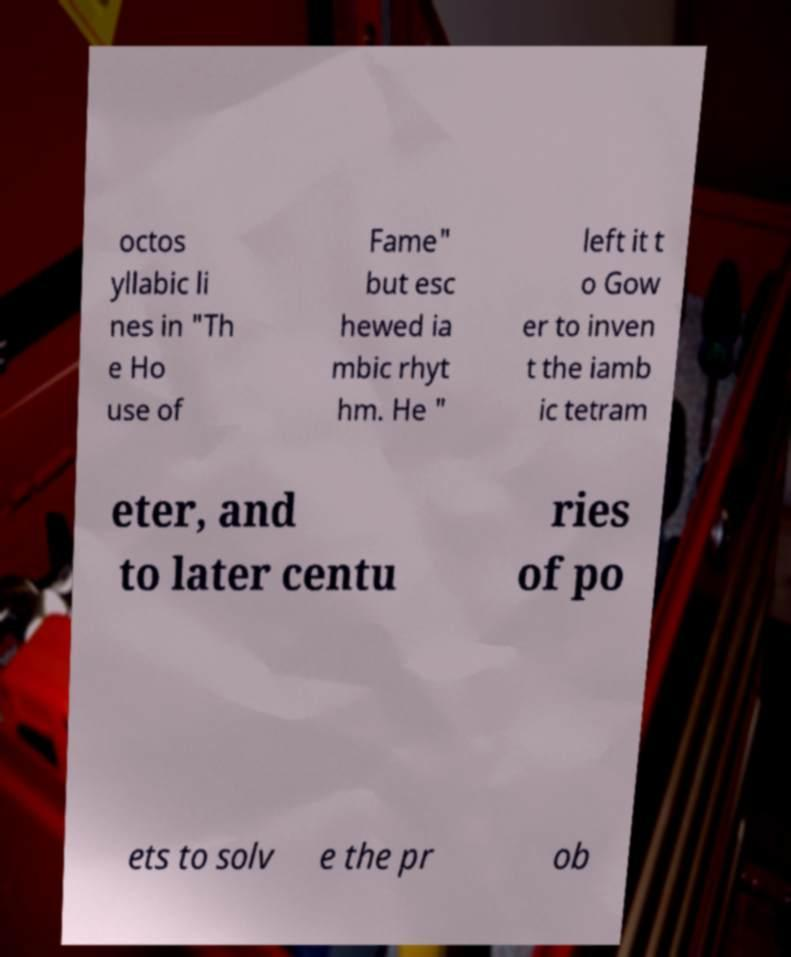What messages or text are displayed in this image? I need them in a readable, typed format. octos yllabic li nes in "Th e Ho use of Fame" but esc hewed ia mbic rhyt hm. He " left it t o Gow er to inven t the iamb ic tetram eter, and to later centu ries of po ets to solv e the pr ob 